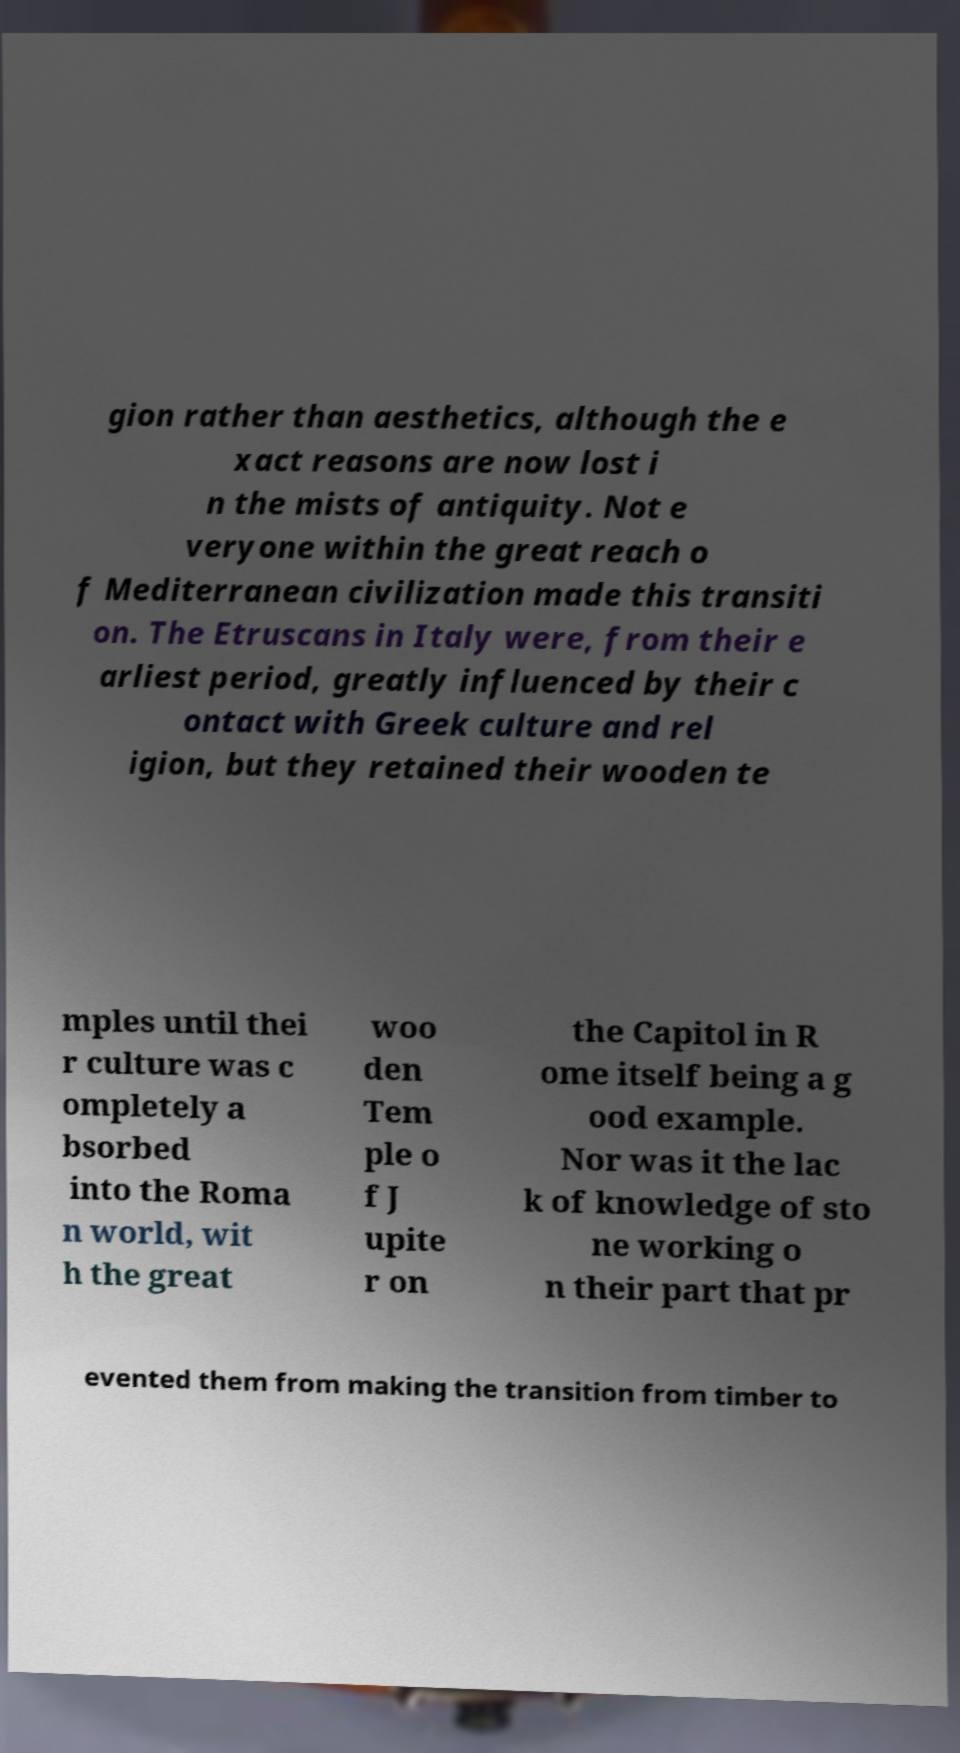For documentation purposes, I need the text within this image transcribed. Could you provide that? gion rather than aesthetics, although the e xact reasons are now lost i n the mists of antiquity. Not e veryone within the great reach o f Mediterranean civilization made this transiti on. The Etruscans in Italy were, from their e arliest period, greatly influenced by their c ontact with Greek culture and rel igion, but they retained their wooden te mples until thei r culture was c ompletely a bsorbed into the Roma n world, wit h the great woo den Tem ple o f J upite r on the Capitol in R ome itself being a g ood example. Nor was it the lac k of knowledge of sto ne working o n their part that pr evented them from making the transition from timber to 